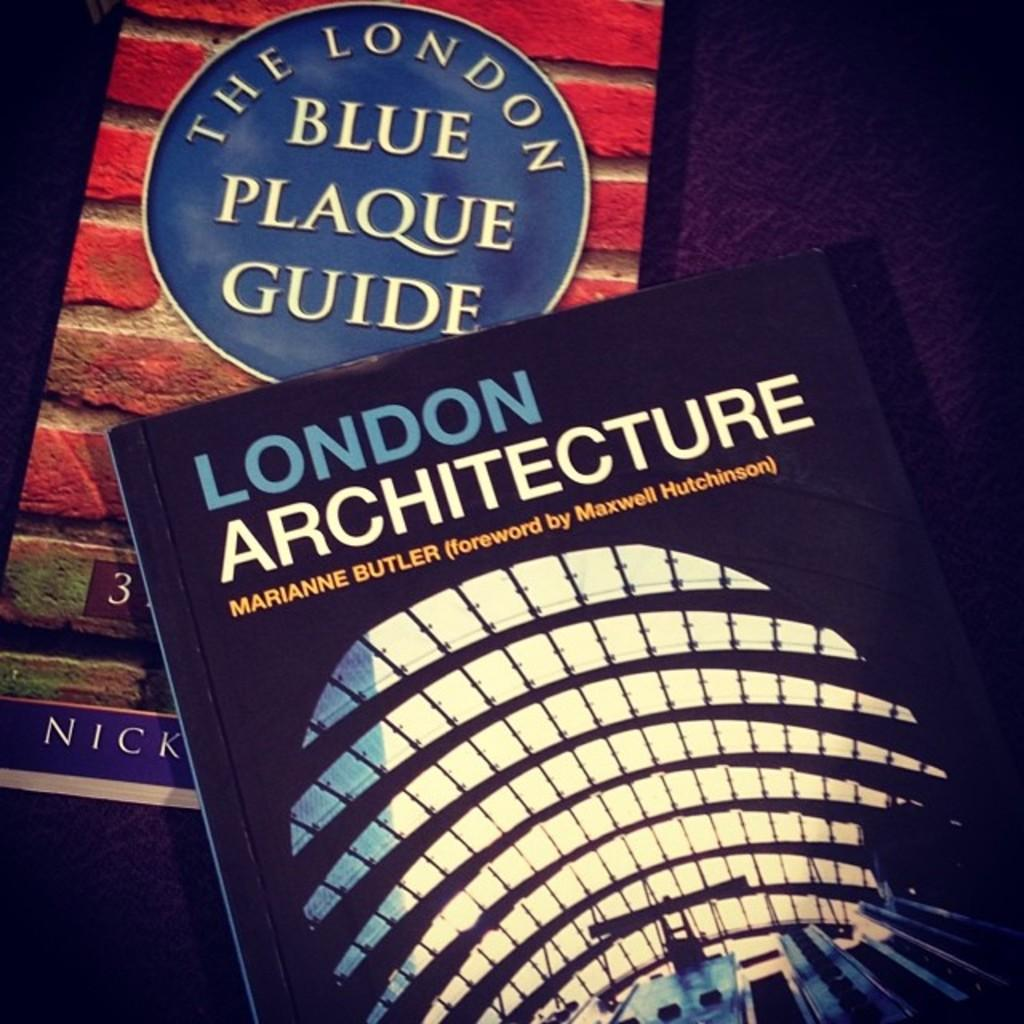<image>
Describe the image concisely. Two different books with both being about London. 